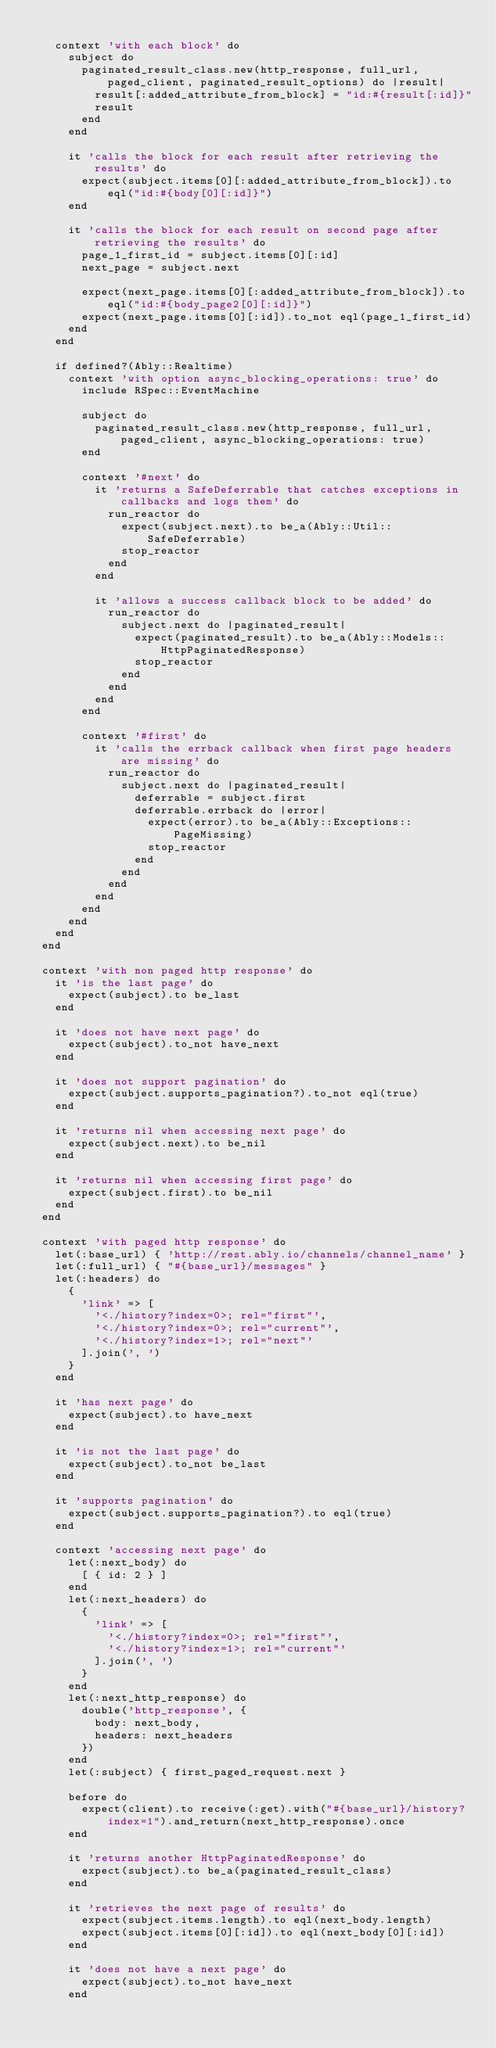<code> <loc_0><loc_0><loc_500><loc_500><_Ruby_>
    context 'with each block' do
      subject do
        paginated_result_class.new(http_response, full_url, paged_client, paginated_result_options) do |result|
          result[:added_attribute_from_block] = "id:#{result[:id]}"
          result
        end
      end

      it 'calls the block for each result after retrieving the results' do
        expect(subject.items[0][:added_attribute_from_block]).to eql("id:#{body[0][:id]}")
      end

      it 'calls the block for each result on second page after retrieving the results' do
        page_1_first_id = subject.items[0][:id]
        next_page = subject.next

        expect(next_page.items[0][:added_attribute_from_block]).to eql("id:#{body_page2[0][:id]}")
        expect(next_page.items[0][:id]).to_not eql(page_1_first_id)
      end
    end

    if defined?(Ably::Realtime)
      context 'with option async_blocking_operations: true' do
        include RSpec::EventMachine

        subject do
          paginated_result_class.new(http_response, full_url, paged_client, async_blocking_operations: true)
        end

        context '#next' do
          it 'returns a SafeDeferrable that catches exceptions in callbacks and logs them' do
            run_reactor do
              expect(subject.next).to be_a(Ably::Util::SafeDeferrable)
              stop_reactor
            end
          end

          it 'allows a success callback block to be added' do
            run_reactor do
              subject.next do |paginated_result|
                expect(paginated_result).to be_a(Ably::Models::HttpPaginatedResponse)
                stop_reactor
              end
            end
          end
        end

        context '#first' do
          it 'calls the errback callback when first page headers are missing' do
            run_reactor do
              subject.next do |paginated_result|
                deferrable = subject.first
                deferrable.errback do |error|
                  expect(error).to be_a(Ably::Exceptions::PageMissing)
                  stop_reactor
                end
              end
            end
          end
        end
      end
    end
  end

  context 'with non paged http response' do
    it 'is the last page' do
      expect(subject).to be_last
    end

    it 'does not have next page' do
      expect(subject).to_not have_next
    end

    it 'does not support pagination' do
      expect(subject.supports_pagination?).to_not eql(true)
    end

    it 'returns nil when accessing next page' do
      expect(subject.next).to be_nil
    end

    it 'returns nil when accessing first page' do
      expect(subject.first).to be_nil
    end
  end

  context 'with paged http response' do
    let(:base_url) { 'http://rest.ably.io/channels/channel_name' }
    let(:full_url) { "#{base_url}/messages" }
    let(:headers) do
      {
        'link' => [
          '<./history?index=0>; rel="first"',
          '<./history?index=0>; rel="current"',
          '<./history?index=1>; rel="next"'
        ].join(', ')
      }
    end

    it 'has next page' do
      expect(subject).to have_next
    end

    it 'is not the last page' do
      expect(subject).to_not be_last
    end

    it 'supports pagination' do
      expect(subject.supports_pagination?).to eql(true)
    end

    context 'accessing next page' do
      let(:next_body) do
        [ { id: 2 } ]
      end
      let(:next_headers) do
        {
          'link' => [
            '<./history?index=0>; rel="first"',
            '<./history?index=1>; rel="current"'
          ].join(', ')
        }
      end
      let(:next_http_response) do
        double('http_response', {
          body: next_body,
          headers: next_headers
        })
      end
      let(:subject) { first_paged_request.next }

      before do
        expect(client).to receive(:get).with("#{base_url}/history?index=1").and_return(next_http_response).once
      end

      it 'returns another HttpPaginatedResponse' do
        expect(subject).to be_a(paginated_result_class)
      end

      it 'retrieves the next page of results' do
        expect(subject.items.length).to eql(next_body.length)
        expect(subject.items[0][:id]).to eql(next_body[0][:id])
      end

      it 'does not have a next page' do
        expect(subject).to_not have_next
      end
</code> 